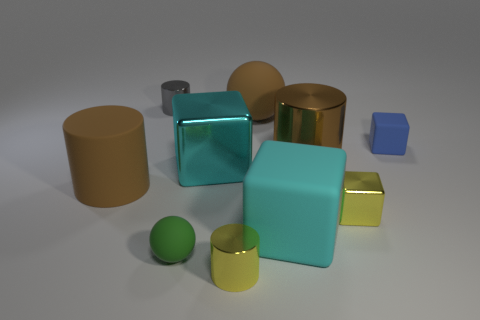What shape is the thing that is the same color as the large rubber cube?
Give a very brief answer. Cube. Is the size of the yellow block the same as the green object?
Provide a short and direct response. Yes. There is a brown cylinder behind the shiny cube behind the brown rubber cylinder; is there a rubber cylinder in front of it?
Provide a succinct answer. Yes. What size is the yellow cube?
Provide a succinct answer. Small. What number of brown matte cylinders have the same size as the green sphere?
Offer a very short reply. 0. There is a yellow thing that is the same shape as the gray metallic thing; what is its material?
Your answer should be compact. Metal. There is a tiny metal thing that is in front of the gray thing and on the left side of the brown metal cylinder; what is its shape?
Your answer should be very brief. Cylinder. What is the shape of the brown matte thing that is to the right of the tiny gray cylinder?
Your answer should be compact. Sphere. What number of rubber things are both in front of the small blue rubber object and behind the tiny ball?
Ensure brevity in your answer.  2. Is the size of the gray thing the same as the sphere in front of the big cyan metal thing?
Provide a succinct answer. Yes. 